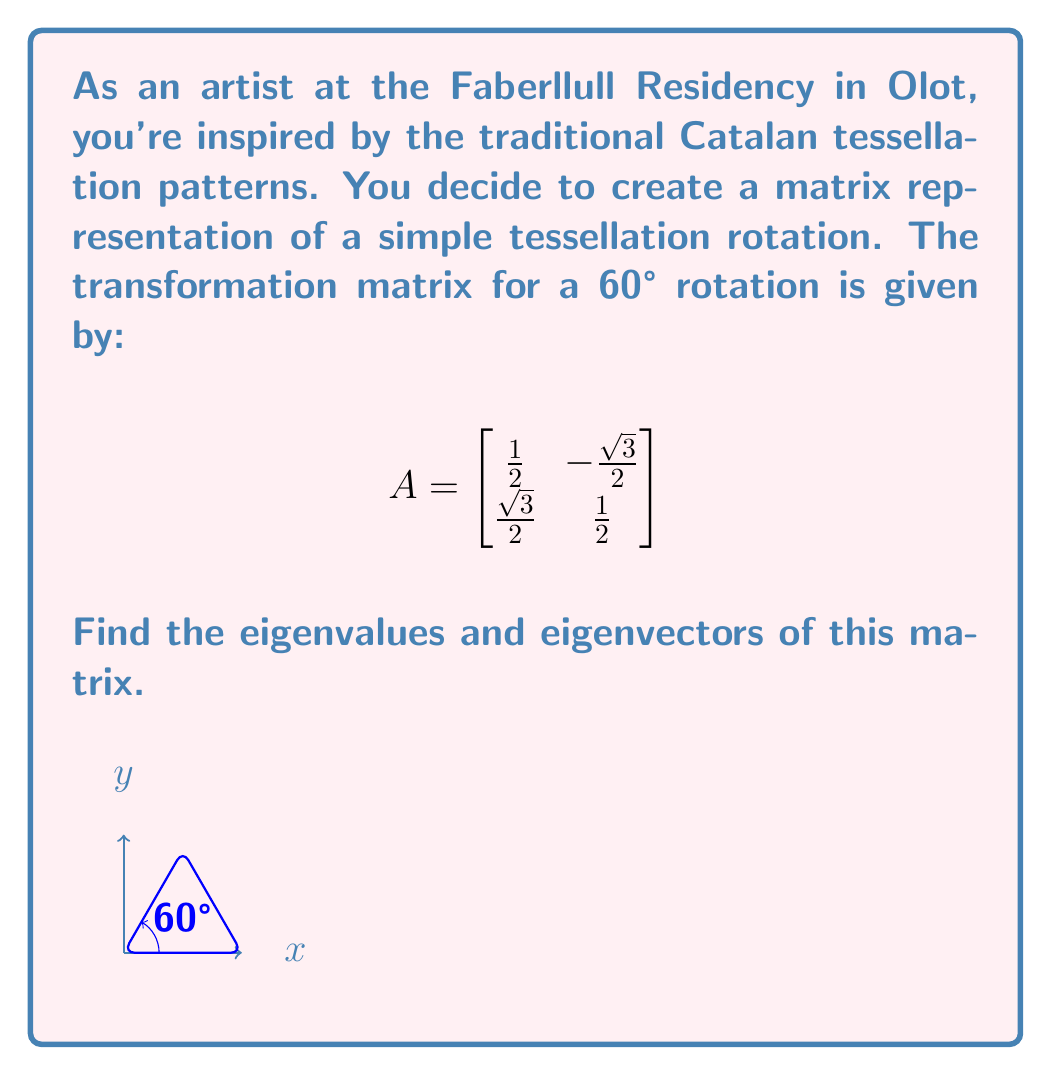Help me with this question. Let's solve this step-by-step:

1) To find eigenvalues, we need to solve the characteristic equation:
   $$\det(A - \lambda I) = 0$$

2) Expand this:
   $$\begin{vmatrix}
   \frac{1}{2} - \lambda & -\frac{\sqrt{3}}{2} \\
   \frac{\sqrt{3}}{2} & \frac{1}{2} - \lambda
   \end{vmatrix} = 0$$

3) Calculate the determinant:
   $$(\frac{1}{2} - \lambda)^2 + (\frac{\sqrt{3}}{2})^2 = 0$$

4) Simplify:
   $$\frac{1}{4} - \lambda + \lambda^2 + \frac{3}{4} = 0$$
   $$\lambda^2 - \lambda + 1 = 0$$

5) This is a quadratic equation. Solve using the quadratic formula:
   $$\lambda = \frac{1 \pm \sqrt{1^2 - 4(1)(1)}}{2(1)} = \frac{1 \pm \sqrt{-3}}{2}$$

6) Therefore, the eigenvalues are:
   $$\lambda_1 = \frac{1 + i\sqrt{3}}{2} \text{ and } \lambda_2 = \frac{1 - i\sqrt{3}}{2}$$

7) For eigenvectors, solve $(A - \lambda I)v = 0$ for each eigenvalue:

   For $\lambda_1 = \frac{1 + i\sqrt{3}}{2}$:
   $$\begin{bmatrix}
   -\frac{i\sqrt{3}}{2} & -\frac{\sqrt{3}}{2} \\
   \frac{\sqrt{3}}{2} & -\frac{i\sqrt{3}}{2}
   \end{bmatrix} \begin{bmatrix} v_1 \\ v_2 \end{bmatrix} = \begin{bmatrix} 0 \\ 0 \end{bmatrix}$$

   Solving this gives us: $v_1 = 1, v_2 = i$

   For $\lambda_2 = \frac{1 - i\sqrt{3}}{2}$:
   $$\begin{bmatrix}
   \frac{i\sqrt{3}}{2} & -\frac{\sqrt{3}}{2} \\
   \frac{\sqrt{3}}{2} & \frac{i\sqrt{3}}{2}
   \end{bmatrix} \begin{bmatrix} v_1 \\ v_2 \end{bmatrix} = \begin{bmatrix} 0 \\ 0 \end{bmatrix}$$

   Solving this gives us: $v_1 = 1, v_2 = -i$
Answer: Eigenvalues: $\lambda_1 = \frac{1 + i\sqrt{3}}{2}, \lambda_2 = \frac{1 - i\sqrt{3}}{2}$
Eigenvectors: $v_1 = \begin{bmatrix} 1 \\ i \end{bmatrix}, v_2 = \begin{bmatrix} 1 \\ -i \end{bmatrix}$ 